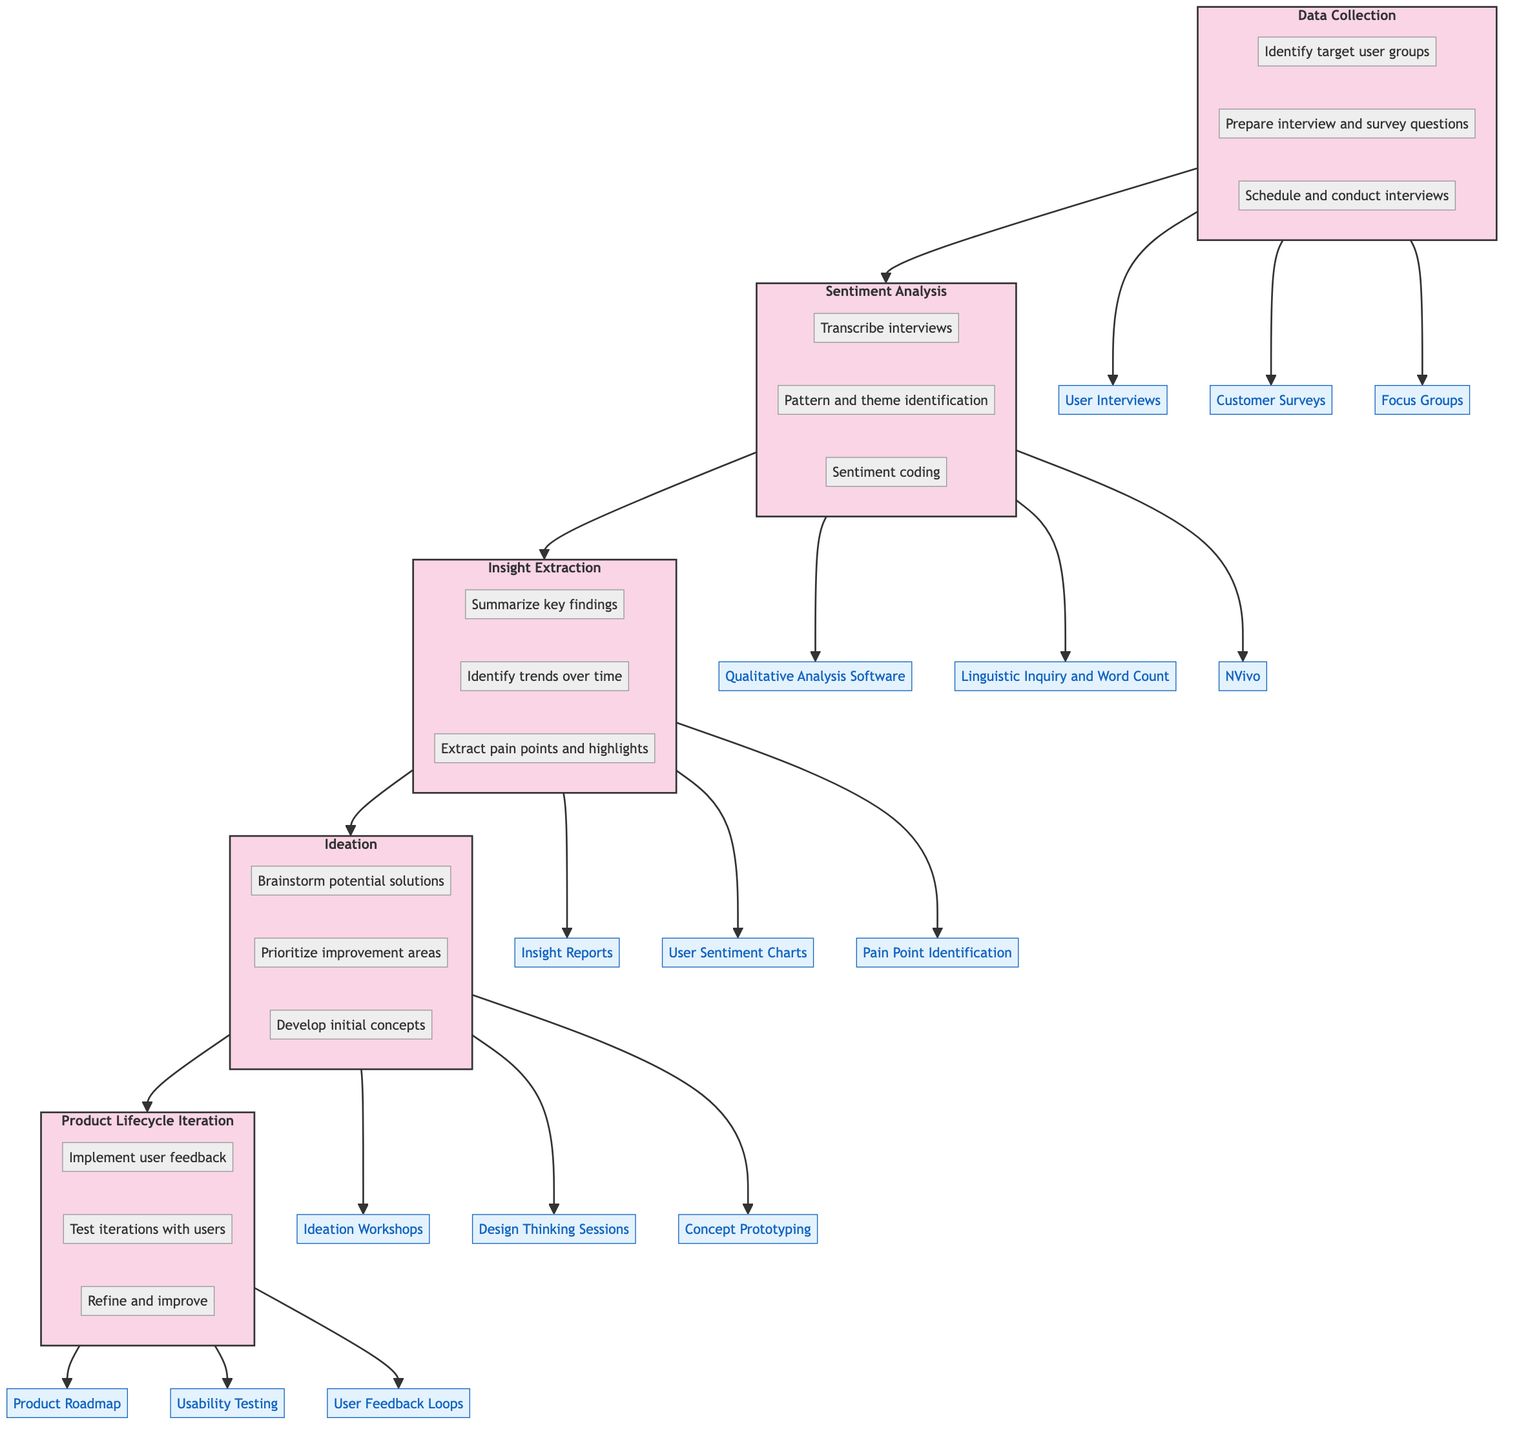What is the first stage in the diagram? The first stage in the flow chart is "Data Collection." It is the bottom-most stage and initiates the process of understanding user sentiment over a product lifecycle.
Answer: Data Collection How many stages are there in the diagram? The diagram includes five stages: Data Collection, Sentiment Analysis, Insight Extraction, Ideation, and Product Lifecycle Iteration. Counting each of these distinct stages gives a total of five.
Answer: Five What follows after the Insight Extraction stage? "Ideation" directly follows the Insight Extraction stage in the flow, as indicated by the flow arrows from one stage to the next.
Answer: Ideation Which entities are associated with the Ideation stage? The entities linked to the Ideation stage in the diagram are Ideation Workshops, Design Thinking Sessions, and Concept Prototyping. These are shown as outputs from the Ideation stage.
Answer: Ideation Workshops, Design Thinking Sessions, Concept Prototyping How does product feedback influence the flow? Product feedback is implemented during the Product Lifecycle Iteration stage, directly impacting the refinement and improvement of product features, as the arrow from Ideation leads to this stage. It shows that the insights from ideation directly lead to iterations based on user feedback.
Answer: Refine and improve What activities occur in the Sentiment Analysis stage? The activities in the Sentiment Analysis stage include Transcribe interviews, Pattern and theme identification, and Sentiment coding. These activities are essential for understanding user sentiment from the collected data.
Answer: Transcribe interviews, Pattern and theme identification, Sentiment coding Why is the "Insight Extraction" stage crucial? The Insight Extraction stage is crucial because it summarizes key findings, identifies trends over time, and extracts pain points and highlights from user feedback, laying the foundation for further development in ideation. This ensures that the development based on user insight is informed and targeted.
Answer: Summarize key findings Which stage includes user feedback loops as an entity? The entity "User Feedback Loops" is associated with the Product Lifecycle Iteration stage, indicating that this stage is focused on implementing user feedback into the product.
Answer: Product Lifecycle Iteration What relationships exist between Data Collection and Sentiment Analysis? Data Collection leads directly to Sentiment Analysis, indicated by the arrow showing the progression from collecting data through interviews and surveys to analyzing the gathered sentiment from those interactions.
Answer: Data Collection → Sentiment Analysis 